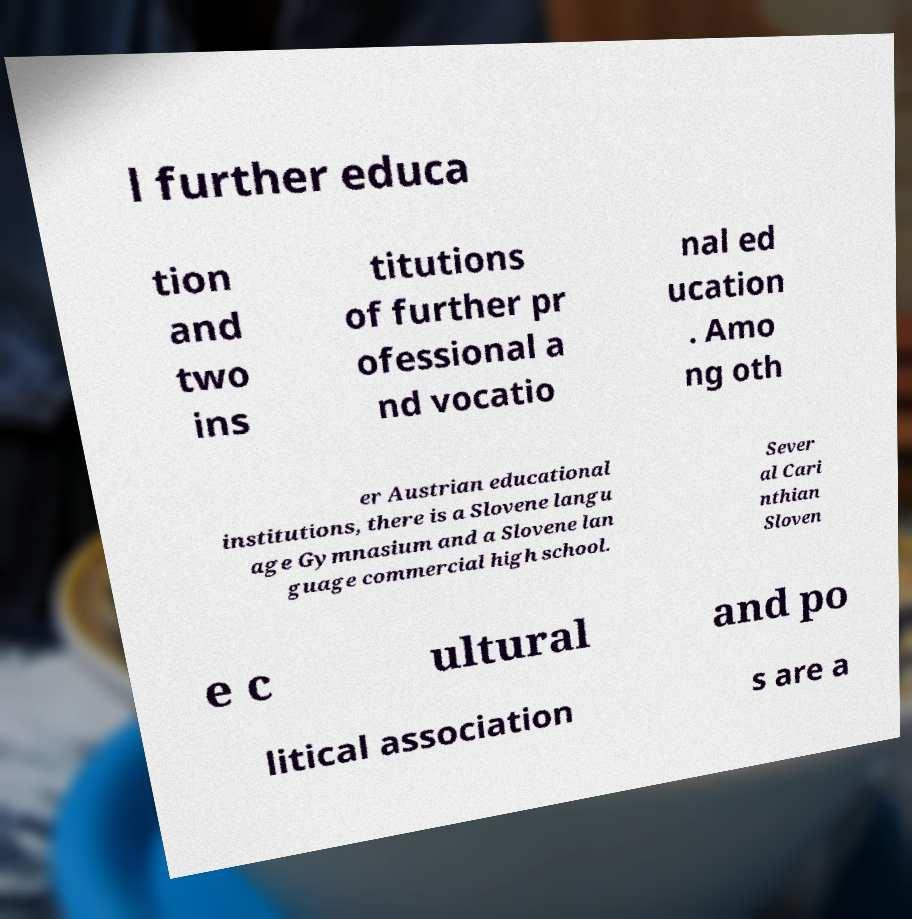Please identify and transcribe the text found in this image. l further educa tion and two ins titutions of further pr ofessional a nd vocatio nal ed ucation . Amo ng oth er Austrian educational institutions, there is a Slovene langu age Gymnasium and a Slovene lan guage commercial high school. Sever al Cari nthian Sloven e c ultural and po litical association s are a 